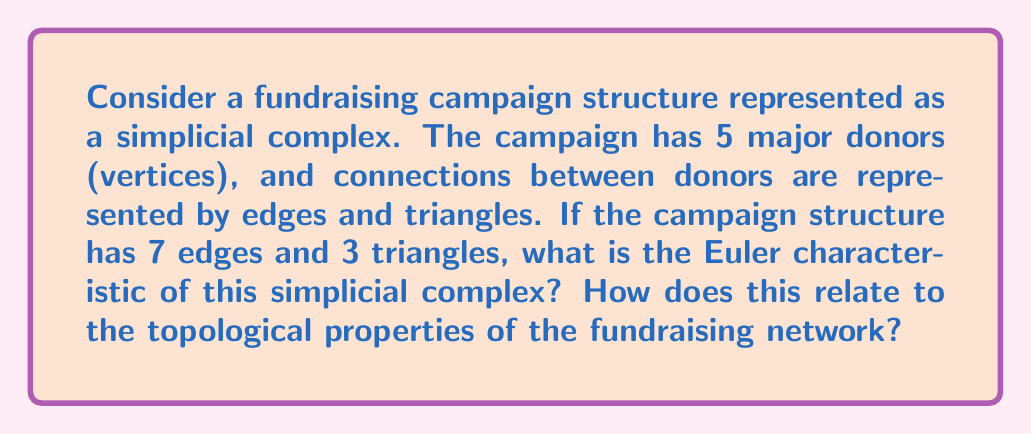Teach me how to tackle this problem. To solve this problem, we'll follow these steps:

1. Understand the components of the simplicial complex:
   - Vertices (0-simplices): 5 major donors
   - Edges (1-simplices): 7 connections between donors
   - Triangles (2-simplices): 3 groups of three interconnected donors

2. Recall the formula for the Euler characteristic of a simplicial complex:
   $$\chi = \sum_{i=0}^{\infty} (-1)^i f_i$$
   where $f_i$ is the number of $i$-dimensional simplices.

3. Calculate the Euler characteristic:
   $$\chi = f_0 - f_1 + f_2$$
   $$\chi = 5 - 7 + 3 = 1$$

4. Interpret the result:
   The Euler characteristic of 1 suggests that the fundraising network has the same topological properties as a tree or a contractible space. This implies that the network is connected and has no holes or voids.

5. Relation to fundraising campaign structure:
   - The positive Euler characteristic indicates a well-connected network of major donors.
   - The lack of holes suggests that there are no significant gaps in the communication or collaboration between donors.
   - The tree-like structure implies that information or influence can efficiently spread through the network.
   - This topological analysis can help the social entrepreneur identify key donors and optimize the campaign structure for better fundraising outcomes.
Answer: The Euler characteristic of the fundraising campaign structure is 1. This indicates that the network has similar topological properties to a tree or contractible space, suggesting a well-connected and efficient donor network without significant gaps or isolated subgroups. 